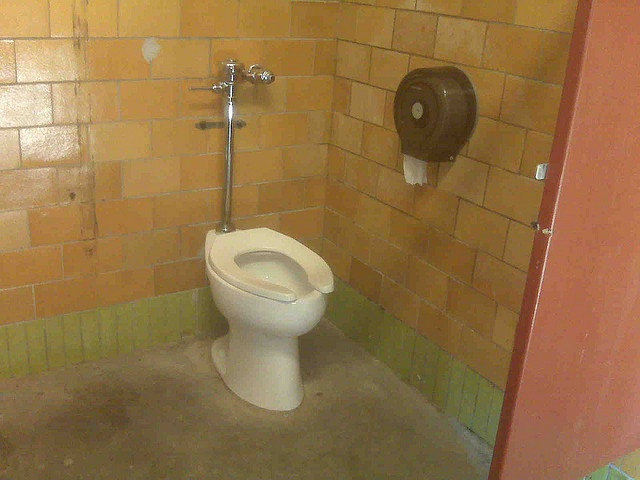Describe the objects in this image and their specific colors. I can see a toilet in tan tones in this image. 